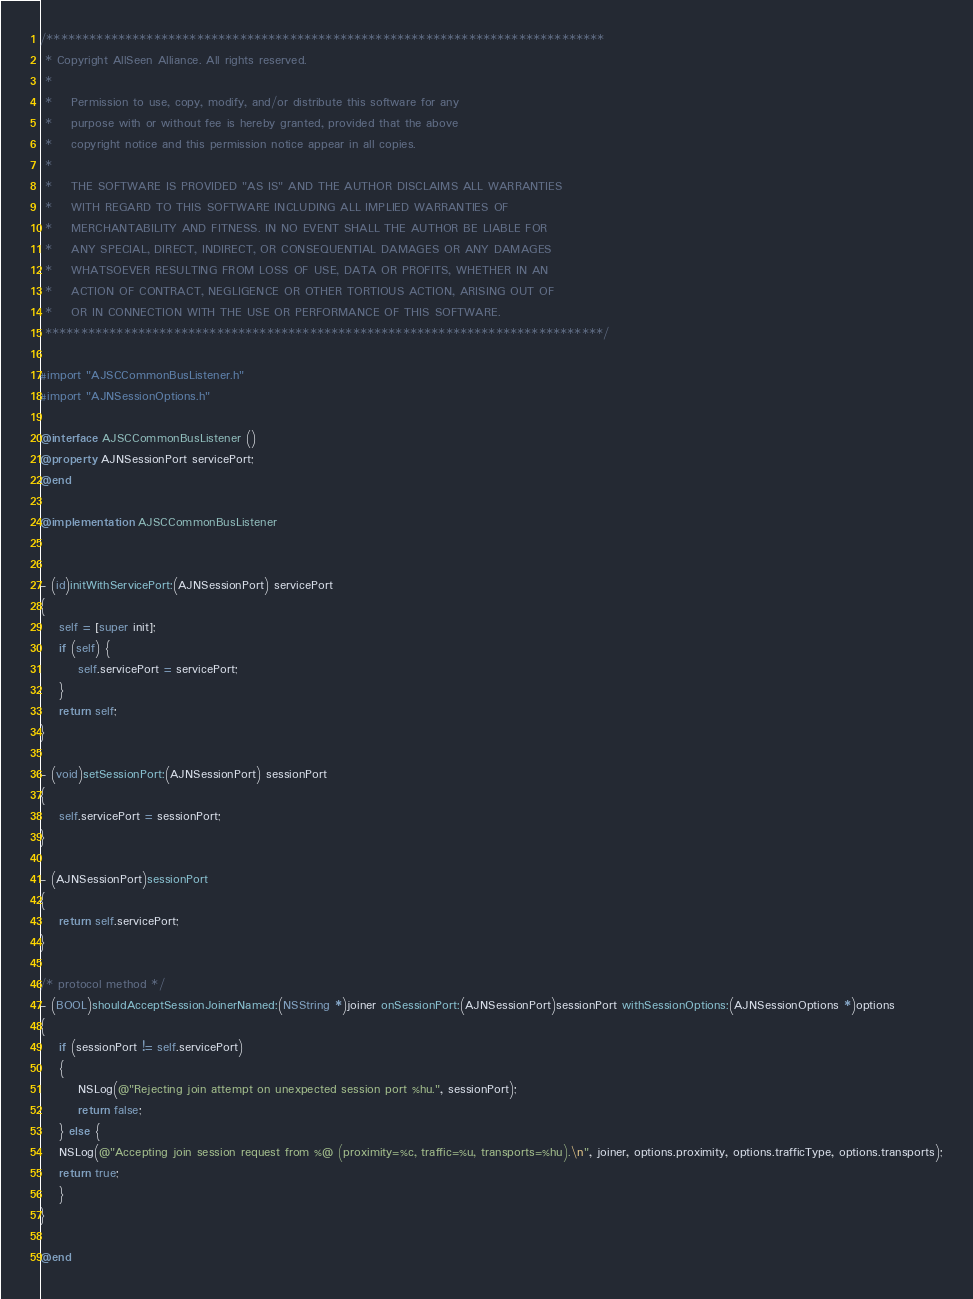<code> <loc_0><loc_0><loc_500><loc_500><_ObjectiveC_>/******************************************************************************
 * Copyright AllSeen Alliance. All rights reserved.
 *
 *    Permission to use, copy, modify, and/or distribute this software for any
 *    purpose with or without fee is hereby granted, provided that the above
 *    copyright notice and this permission notice appear in all copies.
 *
 *    THE SOFTWARE IS PROVIDED "AS IS" AND THE AUTHOR DISCLAIMS ALL WARRANTIES
 *    WITH REGARD TO THIS SOFTWARE INCLUDING ALL IMPLIED WARRANTIES OF
 *    MERCHANTABILITY AND FITNESS. IN NO EVENT SHALL THE AUTHOR BE LIABLE FOR
 *    ANY SPECIAL, DIRECT, INDIRECT, OR CONSEQUENTIAL DAMAGES OR ANY DAMAGES
 *    WHATSOEVER RESULTING FROM LOSS OF USE, DATA OR PROFITS, WHETHER IN AN
 *    ACTION OF CONTRACT, NEGLIGENCE OR OTHER TORTIOUS ACTION, ARISING OUT OF
 *    OR IN CONNECTION WITH THE USE OR PERFORMANCE OF THIS SOFTWARE.
 ******************************************************************************/

#import "AJSCCommonBusListener.h"
#import "AJNSessionOptions.h"

@interface AJSCCommonBusListener ()
@property AJNSessionPort servicePort;
@end

@implementation AJSCCommonBusListener


- (id)initWithServicePort:(AJNSessionPort) servicePort
{
    self = [super init];
    if (self) {
        self.servicePort = servicePort;
    }
    return self;
}

- (void)setSessionPort:(AJNSessionPort) sessionPort
{
    self.servicePort = sessionPort;
}

- (AJNSessionPort)sessionPort
{
    return self.servicePort;
}

/* protocol method */
- (BOOL)shouldAcceptSessionJoinerNamed:(NSString *)joiner onSessionPort:(AJNSessionPort)sessionPort withSessionOptions:(AJNSessionOptions *)options
{
    if (sessionPort != self.servicePort)
    {
        NSLog(@"Rejecting join attempt on unexpected session port %hu.", sessionPort);
        return false;
    } else {
    NSLog(@"Accepting join session request from %@ (proximity=%c, traffic=%u, transports=%hu).\n", joiner, options.proximity, options.trafficType, options.transports);
    return true;
    }
}

@end
</code> 